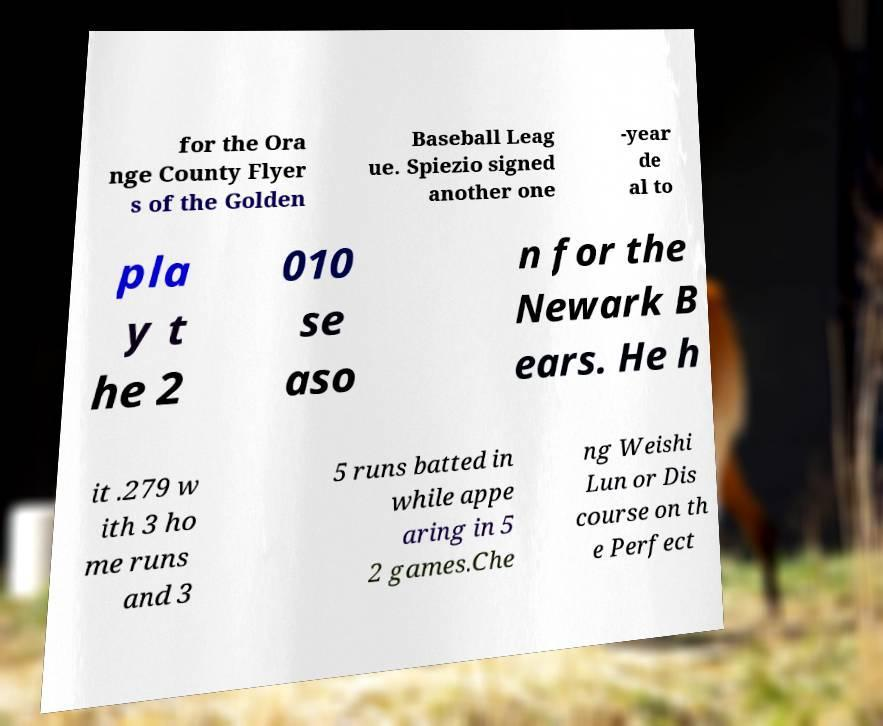Could you assist in decoding the text presented in this image and type it out clearly? for the Ora nge County Flyer s of the Golden Baseball Leag ue. Spiezio signed another one -year de al to pla y t he 2 010 se aso n for the Newark B ears. He h it .279 w ith 3 ho me runs and 3 5 runs batted in while appe aring in 5 2 games.Che ng Weishi Lun or Dis course on th e Perfect 